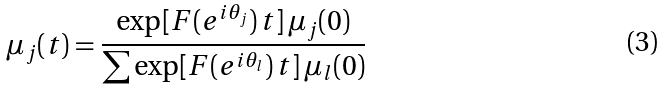<formula> <loc_0><loc_0><loc_500><loc_500>\mu _ { j } ( t ) = \frac { \exp [ F ( e ^ { i \theta _ { j } } ) \, t ] \, \mu _ { j } ( 0 ) } { \sum \exp [ F ( e ^ { i \theta _ { l } } ) \, t ] \, \mu _ { l } ( 0 ) }</formula> 